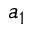Convert formula to latex. <formula><loc_0><loc_0><loc_500><loc_500>a _ { 1 }</formula> 